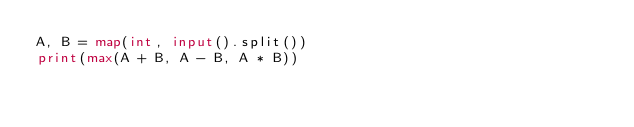<code> <loc_0><loc_0><loc_500><loc_500><_Python_>A, B = map(int, input().split())
print(max(A + B, A - B, A * B))</code> 